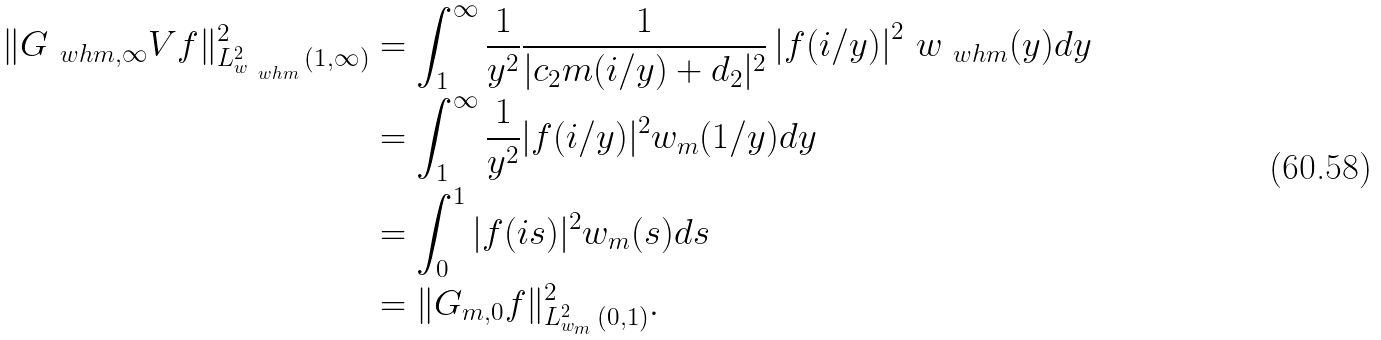Convert formula to latex. <formula><loc_0><loc_0><loc_500><loc_500>\| G _ { \ w h { m } , \infty } V f \| ^ { 2 } _ { L _ { w _ { \ w h { m } } } ^ { 2 } \, ( 1 , \infty ) } & = \int _ { 1 } ^ { \infty } \frac { 1 } { y ^ { 2 } } \frac { 1 } { | c _ { 2 } m ( i / y ) + d _ { 2 } | ^ { 2 } } \left | f ( i / y ) \right | ^ { 2 } \, w _ { \ w h { m } } ( y ) d y \\ & = \int _ { 1 } ^ { \infty } \frac { 1 } { y ^ { 2 } } | f ( i / y ) | ^ { 2 } w _ { m } ( 1 / y ) d y \\ & = \int _ { 0 } ^ { 1 } | f ( i s ) | ^ { 2 } w _ { m } ( s ) d s \\ & = \| G _ { m , 0 } f \| ^ { 2 } _ { L _ { w _ { m } } ^ { 2 } \, ( 0 , 1 ) } .</formula> 